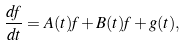Convert formula to latex. <formula><loc_0><loc_0><loc_500><loc_500>\frac { d f } { d t } = A ( t ) f + B ( t ) f + g ( t ) ,</formula> 